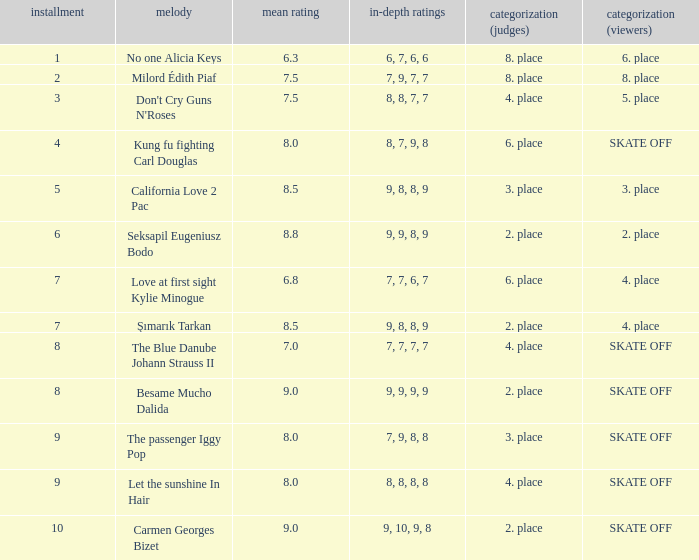Name the average grade for şımarık tarkan 8.5. 